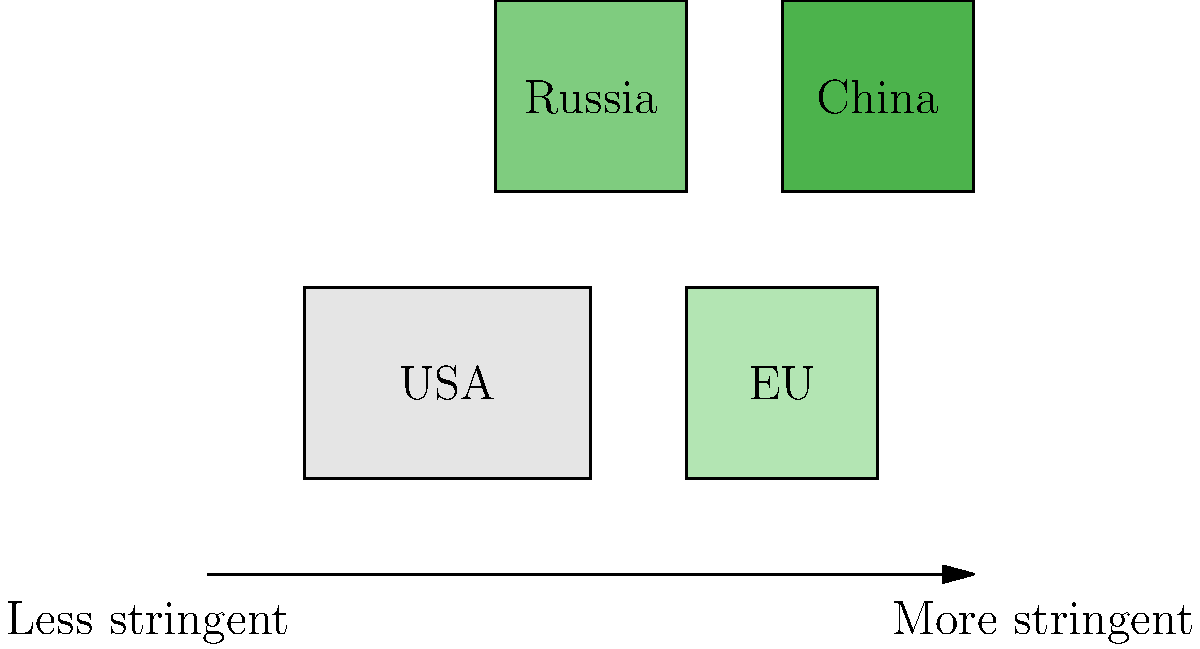Based on the color-coded world map showing the stringency of cybercrime laws, which country appears to have the most stringent cybercrime legislation? To answer this question, we need to analyze the color-coding of the map and understand its legend:

1. The map shows four major regions: USA, EU, Russia, and China.
2. The color gradient ranges from light to dark green, as indicated by the arrow below the map.
3. The legend states that lighter colors represent "Less stringent" laws, while darker colors represent "More stringent" laws.
4. Examining the colors of each region:
   a. USA: Lightest shade of green
   b. EU: Second lightest shade of green
   c. Russia: Second darkest shade of green
   d. China: Darkest shade of green
5. Since China is represented by the darkest shade of green, it corresponds to the most stringent cybercrime legislation according to this map.

This type of visual representation is useful for quickly comparing legislative approaches across different countries, which is particularly relevant for a law student interested in using modern technology to improve understanding of legal systems.
Answer: China 